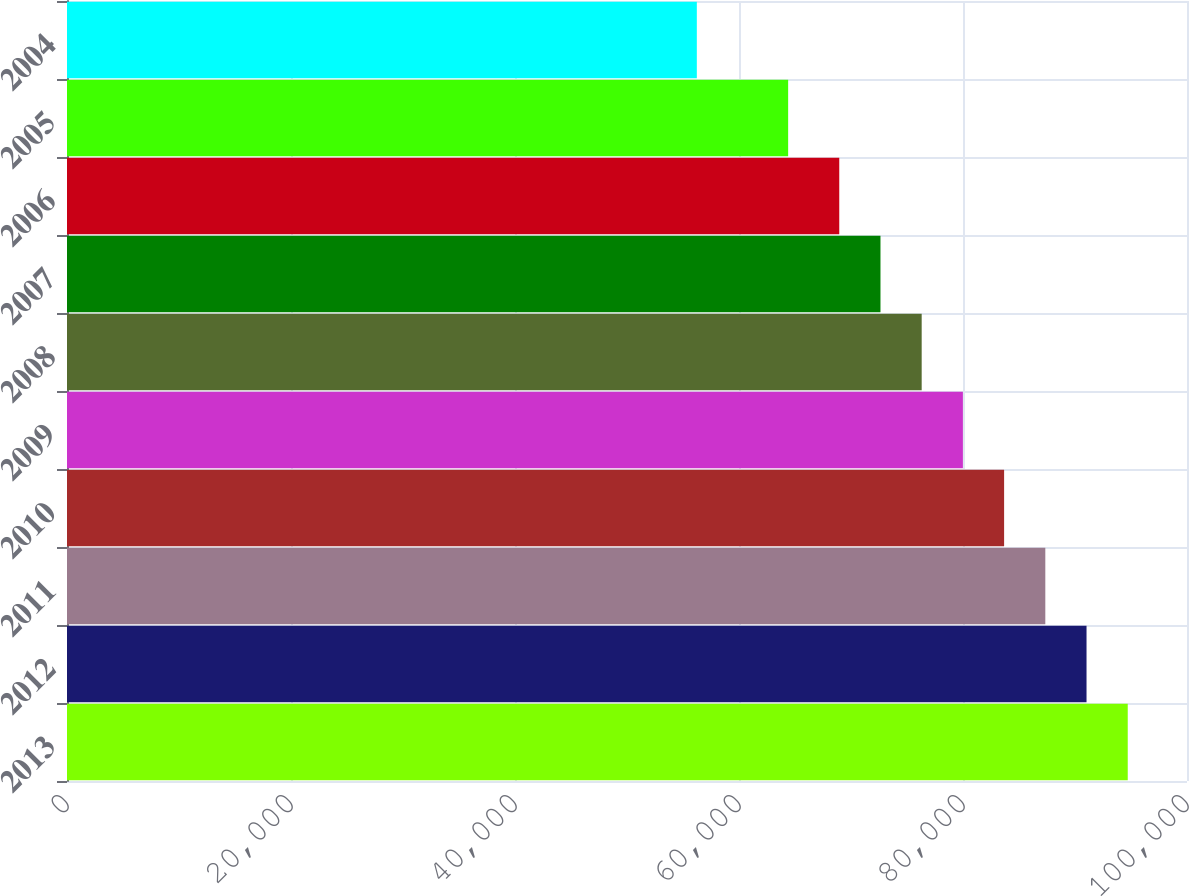Convert chart to OTSL. <chart><loc_0><loc_0><loc_500><loc_500><bar_chart><fcel>2013<fcel>2012<fcel>2011<fcel>2010<fcel>2009<fcel>2008<fcel>2007<fcel>2006<fcel>2005<fcel>2004<nl><fcel>94709.2<fcel>91029.6<fcel>87350<fcel>83670.4<fcel>79990.8<fcel>76311.2<fcel>72631.6<fcel>68952<fcel>64388<fcel>56235<nl></chart> 